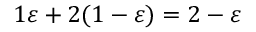<formula> <loc_0><loc_0><loc_500><loc_500>1 \varepsilon + 2 ( 1 - \varepsilon ) = 2 - \varepsilon</formula> 